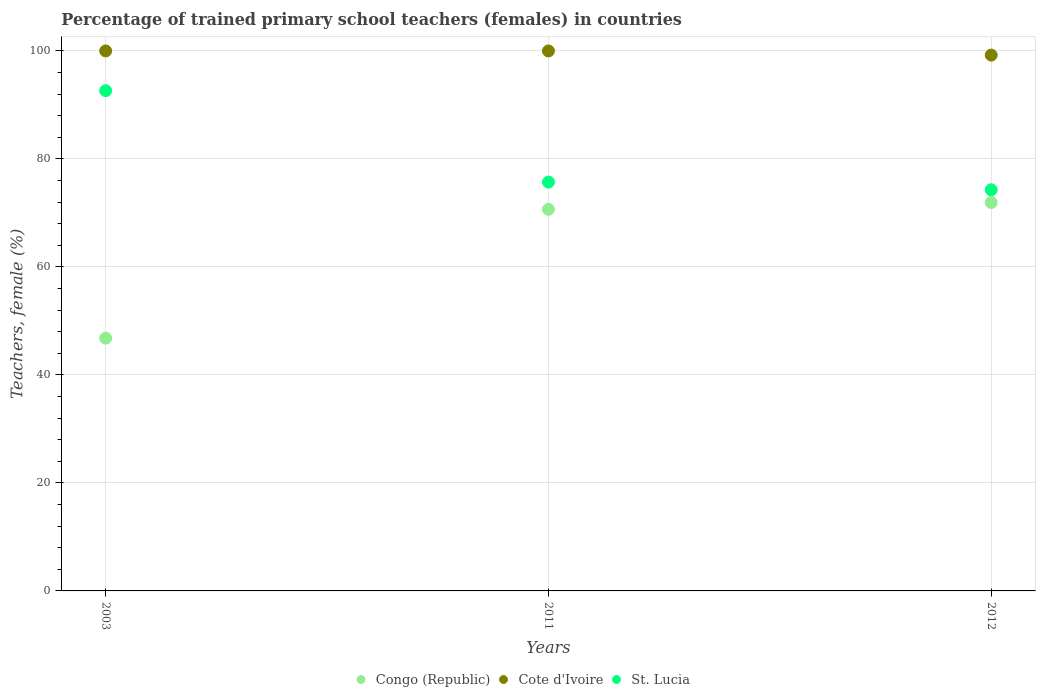How many different coloured dotlines are there?
Offer a very short reply. 3. What is the percentage of trained primary school teachers (females) in Congo (Republic) in 2003?
Provide a succinct answer. 46.81. Across all years, what is the maximum percentage of trained primary school teachers (females) in Congo (Republic)?
Your answer should be compact. 71.93. Across all years, what is the minimum percentage of trained primary school teachers (females) in Congo (Republic)?
Provide a succinct answer. 46.81. In which year was the percentage of trained primary school teachers (females) in St. Lucia minimum?
Offer a very short reply. 2012. What is the total percentage of trained primary school teachers (females) in Congo (Republic) in the graph?
Keep it short and to the point. 189.42. What is the difference between the percentage of trained primary school teachers (females) in Congo (Republic) in 2011 and that in 2012?
Provide a short and direct response. -1.25. What is the difference between the percentage of trained primary school teachers (females) in Cote d'Ivoire in 2003 and the percentage of trained primary school teachers (females) in St. Lucia in 2012?
Your response must be concise. 25.71. What is the average percentage of trained primary school teachers (females) in Cote d'Ivoire per year?
Your answer should be very brief. 99.74. In the year 2012, what is the difference between the percentage of trained primary school teachers (females) in St. Lucia and percentage of trained primary school teachers (females) in Congo (Republic)?
Ensure brevity in your answer.  2.36. What is the ratio of the percentage of trained primary school teachers (females) in Congo (Republic) in 2011 to that in 2012?
Ensure brevity in your answer.  0.98. Is the difference between the percentage of trained primary school teachers (females) in St. Lucia in 2003 and 2012 greater than the difference between the percentage of trained primary school teachers (females) in Congo (Republic) in 2003 and 2012?
Offer a terse response. Yes. What is the difference between the highest and the second highest percentage of trained primary school teachers (females) in St. Lucia?
Offer a terse response. 16.92. What is the difference between the highest and the lowest percentage of trained primary school teachers (females) in St. Lucia?
Make the answer very short. 18.35. In how many years, is the percentage of trained primary school teachers (females) in Congo (Republic) greater than the average percentage of trained primary school teachers (females) in Congo (Republic) taken over all years?
Your answer should be very brief. 2. Is it the case that in every year, the sum of the percentage of trained primary school teachers (females) in Congo (Republic) and percentage of trained primary school teachers (females) in Cote d'Ivoire  is greater than the percentage of trained primary school teachers (females) in St. Lucia?
Your response must be concise. Yes. Does the percentage of trained primary school teachers (females) in Cote d'Ivoire monotonically increase over the years?
Keep it short and to the point. No. Is the percentage of trained primary school teachers (females) in Cote d'Ivoire strictly less than the percentage of trained primary school teachers (females) in Congo (Republic) over the years?
Offer a very short reply. No. What is the difference between two consecutive major ticks on the Y-axis?
Make the answer very short. 20. Are the values on the major ticks of Y-axis written in scientific E-notation?
Your answer should be very brief. No. Does the graph contain any zero values?
Ensure brevity in your answer.  No. Does the graph contain grids?
Offer a very short reply. Yes. How are the legend labels stacked?
Ensure brevity in your answer.  Horizontal. What is the title of the graph?
Your answer should be very brief. Percentage of trained primary school teachers (females) in countries. Does "Canada" appear as one of the legend labels in the graph?
Offer a terse response. No. What is the label or title of the X-axis?
Provide a short and direct response. Years. What is the label or title of the Y-axis?
Your answer should be compact. Teachers, female (%). What is the Teachers, female (%) in Congo (Republic) in 2003?
Your response must be concise. 46.81. What is the Teachers, female (%) in Cote d'Ivoire in 2003?
Offer a very short reply. 100. What is the Teachers, female (%) of St. Lucia in 2003?
Provide a short and direct response. 92.64. What is the Teachers, female (%) of Congo (Republic) in 2011?
Your answer should be very brief. 70.68. What is the Teachers, female (%) in Cote d'Ivoire in 2011?
Your answer should be compact. 100. What is the Teachers, female (%) of St. Lucia in 2011?
Keep it short and to the point. 75.71. What is the Teachers, female (%) of Congo (Republic) in 2012?
Your response must be concise. 71.93. What is the Teachers, female (%) of Cote d'Ivoire in 2012?
Offer a terse response. 99.23. What is the Teachers, female (%) of St. Lucia in 2012?
Your response must be concise. 74.29. Across all years, what is the maximum Teachers, female (%) of Congo (Republic)?
Your answer should be compact. 71.93. Across all years, what is the maximum Teachers, female (%) of St. Lucia?
Offer a very short reply. 92.64. Across all years, what is the minimum Teachers, female (%) in Congo (Republic)?
Your answer should be very brief. 46.81. Across all years, what is the minimum Teachers, female (%) of Cote d'Ivoire?
Your answer should be compact. 99.23. Across all years, what is the minimum Teachers, female (%) in St. Lucia?
Provide a succinct answer. 74.29. What is the total Teachers, female (%) of Congo (Republic) in the graph?
Give a very brief answer. 189.42. What is the total Teachers, female (%) of Cote d'Ivoire in the graph?
Your answer should be compact. 299.23. What is the total Teachers, female (%) in St. Lucia in the graph?
Your answer should be compact. 242.64. What is the difference between the Teachers, female (%) in Congo (Republic) in 2003 and that in 2011?
Your answer should be compact. -23.86. What is the difference between the Teachers, female (%) in Cote d'Ivoire in 2003 and that in 2011?
Keep it short and to the point. 0. What is the difference between the Teachers, female (%) of St. Lucia in 2003 and that in 2011?
Your answer should be very brief. 16.92. What is the difference between the Teachers, female (%) in Congo (Republic) in 2003 and that in 2012?
Provide a short and direct response. -25.12. What is the difference between the Teachers, female (%) of Cote d'Ivoire in 2003 and that in 2012?
Offer a very short reply. 0.77. What is the difference between the Teachers, female (%) of St. Lucia in 2003 and that in 2012?
Provide a short and direct response. 18.35. What is the difference between the Teachers, female (%) in Congo (Republic) in 2011 and that in 2012?
Your answer should be very brief. -1.25. What is the difference between the Teachers, female (%) in Cote d'Ivoire in 2011 and that in 2012?
Provide a short and direct response. 0.77. What is the difference between the Teachers, female (%) in St. Lucia in 2011 and that in 2012?
Your answer should be very brief. 1.43. What is the difference between the Teachers, female (%) in Congo (Republic) in 2003 and the Teachers, female (%) in Cote d'Ivoire in 2011?
Keep it short and to the point. -53.19. What is the difference between the Teachers, female (%) of Congo (Republic) in 2003 and the Teachers, female (%) of St. Lucia in 2011?
Your response must be concise. -28.9. What is the difference between the Teachers, female (%) in Cote d'Ivoire in 2003 and the Teachers, female (%) in St. Lucia in 2011?
Give a very brief answer. 24.29. What is the difference between the Teachers, female (%) of Congo (Republic) in 2003 and the Teachers, female (%) of Cote d'Ivoire in 2012?
Provide a succinct answer. -52.41. What is the difference between the Teachers, female (%) in Congo (Republic) in 2003 and the Teachers, female (%) in St. Lucia in 2012?
Offer a very short reply. -27.47. What is the difference between the Teachers, female (%) of Cote d'Ivoire in 2003 and the Teachers, female (%) of St. Lucia in 2012?
Your answer should be very brief. 25.71. What is the difference between the Teachers, female (%) of Congo (Republic) in 2011 and the Teachers, female (%) of Cote d'Ivoire in 2012?
Offer a terse response. -28.55. What is the difference between the Teachers, female (%) of Congo (Republic) in 2011 and the Teachers, female (%) of St. Lucia in 2012?
Make the answer very short. -3.61. What is the difference between the Teachers, female (%) of Cote d'Ivoire in 2011 and the Teachers, female (%) of St. Lucia in 2012?
Keep it short and to the point. 25.71. What is the average Teachers, female (%) of Congo (Republic) per year?
Provide a succinct answer. 63.14. What is the average Teachers, female (%) of Cote d'Ivoire per year?
Your answer should be very brief. 99.74. What is the average Teachers, female (%) of St. Lucia per year?
Offer a very short reply. 80.88. In the year 2003, what is the difference between the Teachers, female (%) of Congo (Republic) and Teachers, female (%) of Cote d'Ivoire?
Keep it short and to the point. -53.19. In the year 2003, what is the difference between the Teachers, female (%) in Congo (Republic) and Teachers, female (%) in St. Lucia?
Ensure brevity in your answer.  -45.82. In the year 2003, what is the difference between the Teachers, female (%) of Cote d'Ivoire and Teachers, female (%) of St. Lucia?
Your response must be concise. 7.36. In the year 2011, what is the difference between the Teachers, female (%) in Congo (Republic) and Teachers, female (%) in Cote d'Ivoire?
Offer a terse response. -29.32. In the year 2011, what is the difference between the Teachers, female (%) in Congo (Republic) and Teachers, female (%) in St. Lucia?
Make the answer very short. -5.04. In the year 2011, what is the difference between the Teachers, female (%) in Cote d'Ivoire and Teachers, female (%) in St. Lucia?
Your answer should be compact. 24.29. In the year 2012, what is the difference between the Teachers, female (%) in Congo (Republic) and Teachers, female (%) in Cote d'Ivoire?
Provide a short and direct response. -27.3. In the year 2012, what is the difference between the Teachers, female (%) in Congo (Republic) and Teachers, female (%) in St. Lucia?
Ensure brevity in your answer.  -2.36. In the year 2012, what is the difference between the Teachers, female (%) in Cote d'Ivoire and Teachers, female (%) in St. Lucia?
Offer a very short reply. 24.94. What is the ratio of the Teachers, female (%) of Congo (Republic) in 2003 to that in 2011?
Make the answer very short. 0.66. What is the ratio of the Teachers, female (%) of St. Lucia in 2003 to that in 2011?
Provide a short and direct response. 1.22. What is the ratio of the Teachers, female (%) of Congo (Republic) in 2003 to that in 2012?
Offer a terse response. 0.65. What is the ratio of the Teachers, female (%) in Cote d'Ivoire in 2003 to that in 2012?
Offer a terse response. 1.01. What is the ratio of the Teachers, female (%) of St. Lucia in 2003 to that in 2012?
Give a very brief answer. 1.25. What is the ratio of the Teachers, female (%) in Congo (Republic) in 2011 to that in 2012?
Your answer should be very brief. 0.98. What is the ratio of the Teachers, female (%) in St. Lucia in 2011 to that in 2012?
Your response must be concise. 1.02. What is the difference between the highest and the second highest Teachers, female (%) in Congo (Republic)?
Your response must be concise. 1.25. What is the difference between the highest and the second highest Teachers, female (%) of St. Lucia?
Your answer should be very brief. 16.92. What is the difference between the highest and the lowest Teachers, female (%) of Congo (Republic)?
Provide a succinct answer. 25.12. What is the difference between the highest and the lowest Teachers, female (%) in Cote d'Ivoire?
Offer a terse response. 0.77. What is the difference between the highest and the lowest Teachers, female (%) in St. Lucia?
Your answer should be compact. 18.35. 